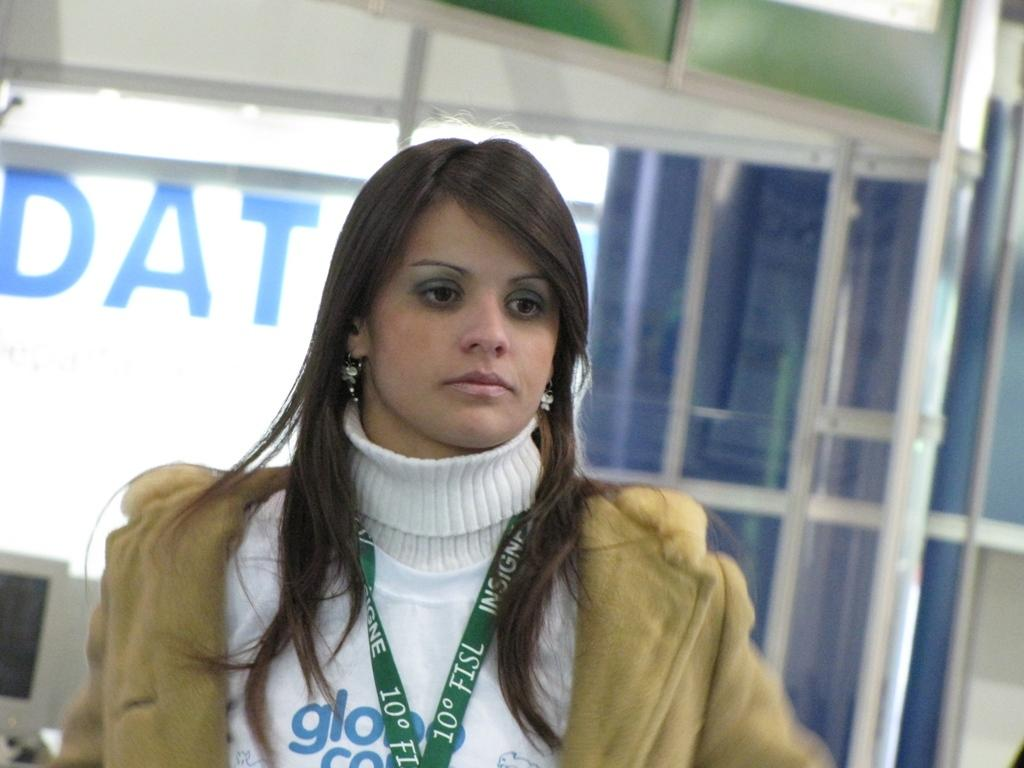Who is present in the image? There is a woman in the image. What can be seen in the background of the image? There is a monitor and other objects in the background of the image. How many ladybugs can be seen on the woman's shoulder in the image? There are no ladybugs present on the woman's shoulder in the image. What type of pen is the woman holding in the image? The woman is not holding a pen in the image. 